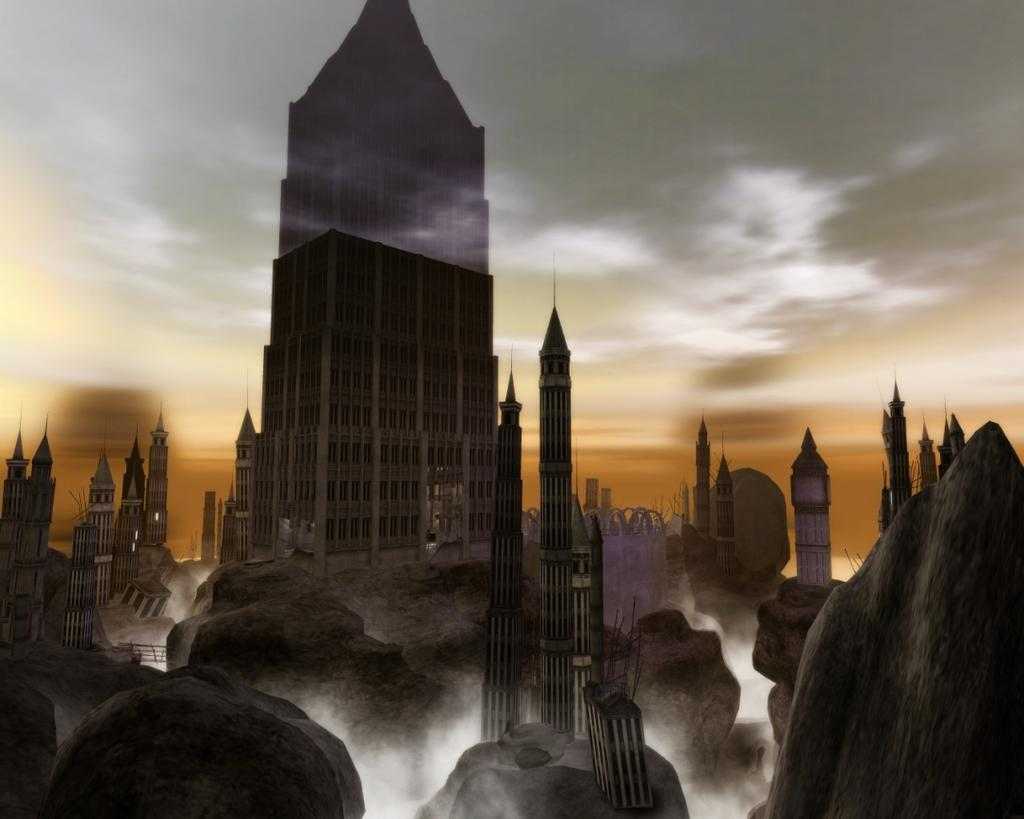What structures are located at the bottom of the image? There are rocks with towers at the bottom of the image. What type of building is in the middle of the image? There is a building with windows in the middle of the image. What can be seen in the background of the image? The sky is visible in the background of the image. What type of metal is used to create the knot in the image? There is no knot present in the image, and therefore no metal can be associated with it. 